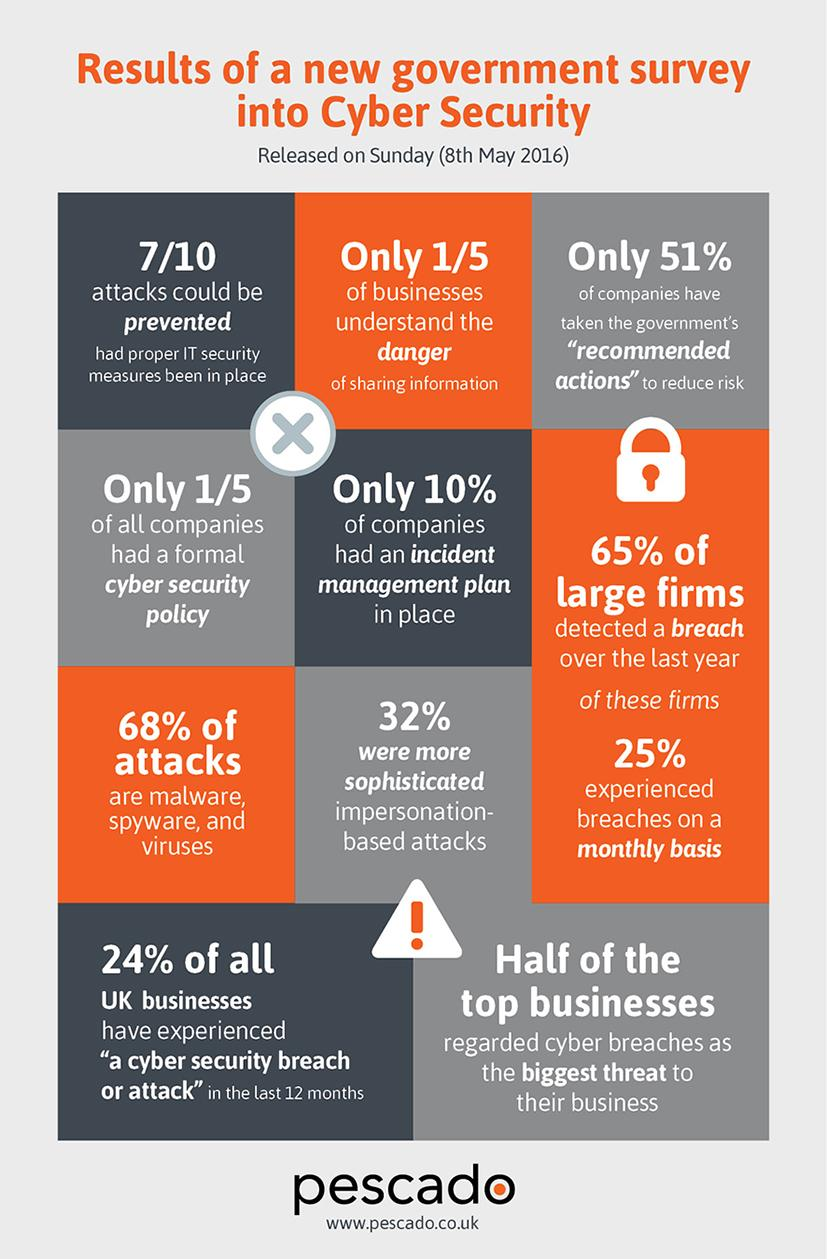Identify some key points in this picture. According to data from the UK as of May 8th, 2016, 68% of cyber attacks involved malware, spyware, and viruses. According to a survey conducted in the UK as of 8th May 2016, approximately 90% of companies do not have an incident management plan in place. According to a survey conducted as of May 8th, 2016, approximately 25% of large firms in the UK experienced cyber breaches on a monthly basis. According to the latest statistics, a large majority of UK businesses, approximately 76%, have not experienced a cyber security breach or attack in the past 12 months. 